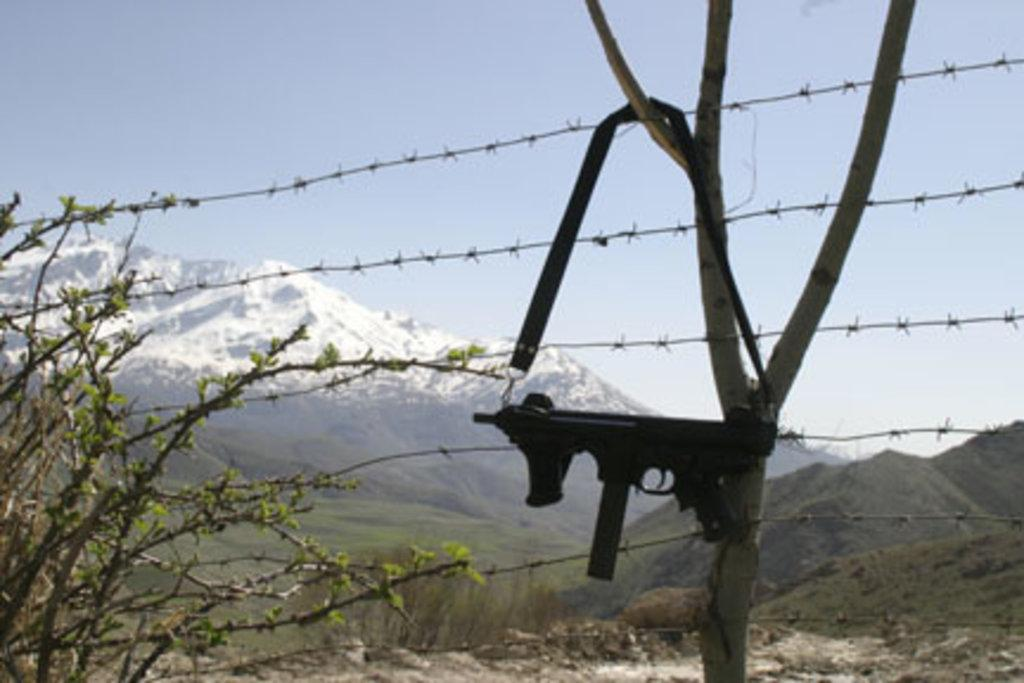What type of barrier can be seen in the image? There is a wire fence in the image. What natural elements are present in the image? There are trees and mountains visible in the image. Can you describe the location of the gun in the image? The gun is hanging from a branch of a tree in the image. What is visible in the background of the image? The sky is visible in the background of the image. What type of creature is sitting on the road in the image? There is no road or creature present in the image. How many times does the creature bite the gun in the image? There is no creature or gun-biting activity present in the image. 